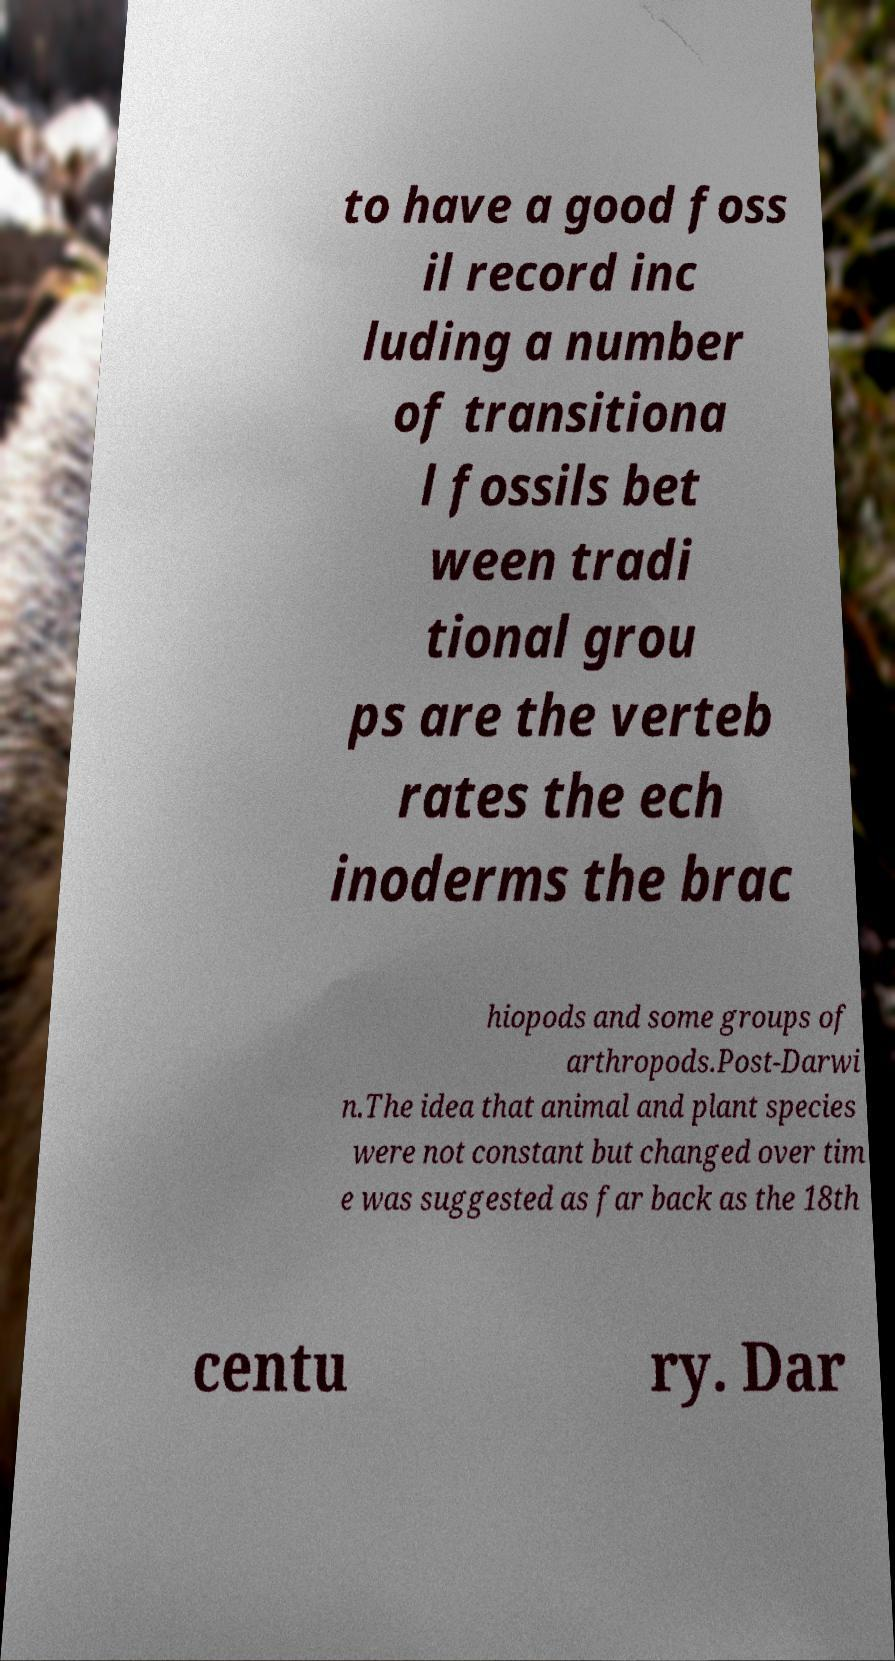Please identify and transcribe the text found in this image. to have a good foss il record inc luding a number of transitiona l fossils bet ween tradi tional grou ps are the verteb rates the ech inoderms the brac hiopods and some groups of arthropods.Post-Darwi n.The idea that animal and plant species were not constant but changed over tim e was suggested as far back as the 18th centu ry. Dar 